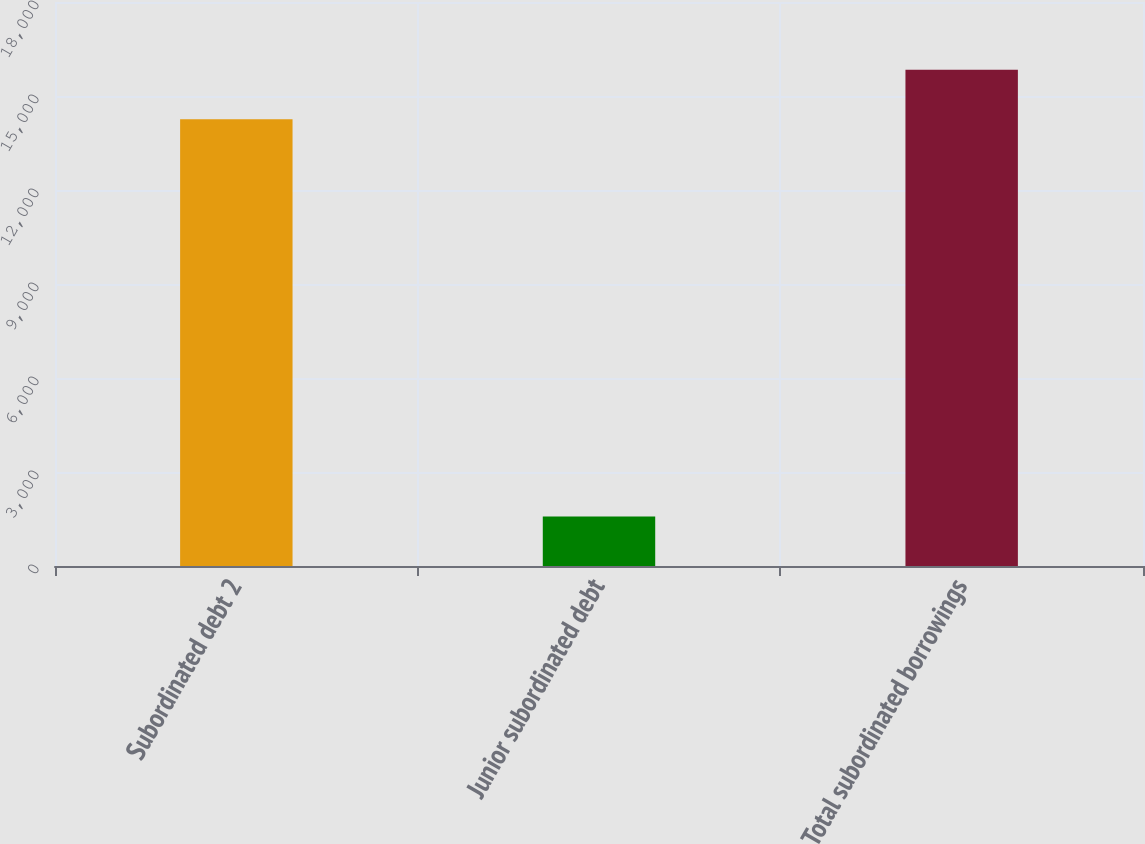<chart> <loc_0><loc_0><loc_500><loc_500><bar_chart><fcel>Subordinated debt 2<fcel>Junior subordinated debt<fcel>Total subordinated borrowings<nl><fcel>14254<fcel>1582<fcel>15836<nl></chart> 